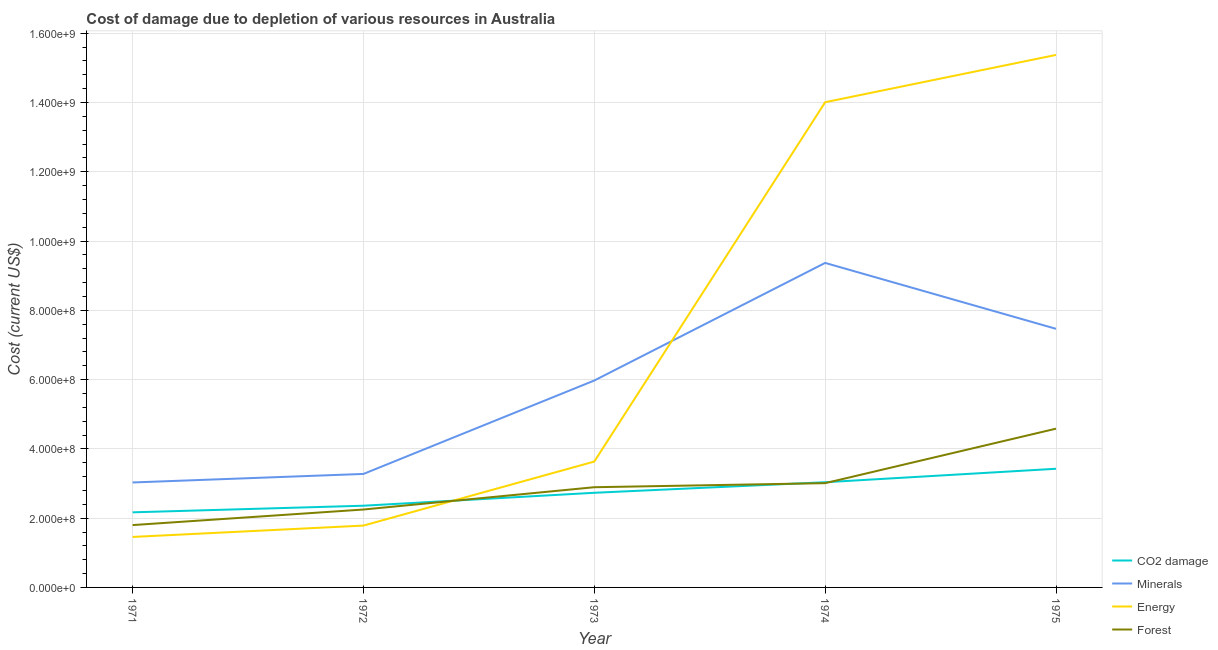Does the line corresponding to cost of damage due to depletion of coal intersect with the line corresponding to cost of damage due to depletion of energy?
Provide a succinct answer. Yes. What is the cost of damage due to depletion of energy in 1974?
Your response must be concise. 1.40e+09. Across all years, what is the maximum cost of damage due to depletion of coal?
Offer a very short reply. 3.43e+08. Across all years, what is the minimum cost of damage due to depletion of minerals?
Offer a terse response. 3.03e+08. In which year was the cost of damage due to depletion of minerals maximum?
Offer a terse response. 1974. What is the total cost of damage due to depletion of coal in the graph?
Offer a terse response. 1.37e+09. What is the difference between the cost of damage due to depletion of minerals in 1971 and that in 1972?
Keep it short and to the point. -2.46e+07. What is the difference between the cost of damage due to depletion of energy in 1975 and the cost of damage due to depletion of coal in 1971?
Provide a succinct answer. 1.32e+09. What is the average cost of damage due to depletion of coal per year?
Provide a succinct answer. 2.74e+08. In the year 1972, what is the difference between the cost of damage due to depletion of energy and cost of damage due to depletion of minerals?
Give a very brief answer. -1.49e+08. What is the ratio of the cost of damage due to depletion of energy in 1971 to that in 1972?
Your answer should be compact. 0.82. Is the cost of damage due to depletion of minerals in 1972 less than that in 1974?
Your answer should be very brief. Yes. Is the difference between the cost of damage due to depletion of energy in 1973 and 1975 greater than the difference between the cost of damage due to depletion of minerals in 1973 and 1975?
Ensure brevity in your answer.  No. What is the difference between the highest and the second highest cost of damage due to depletion of coal?
Your response must be concise. 3.89e+07. What is the difference between the highest and the lowest cost of damage due to depletion of energy?
Keep it short and to the point. 1.39e+09. In how many years, is the cost of damage due to depletion of minerals greater than the average cost of damage due to depletion of minerals taken over all years?
Make the answer very short. 3. Is it the case that in every year, the sum of the cost of damage due to depletion of minerals and cost of damage due to depletion of forests is greater than the sum of cost of damage due to depletion of coal and cost of damage due to depletion of energy?
Provide a short and direct response. No. Does the cost of damage due to depletion of coal monotonically increase over the years?
Your answer should be compact. Yes. How many lines are there?
Give a very brief answer. 4. What is the difference between two consecutive major ticks on the Y-axis?
Provide a succinct answer. 2.00e+08. How many legend labels are there?
Offer a very short reply. 4. What is the title of the graph?
Provide a succinct answer. Cost of damage due to depletion of various resources in Australia . What is the label or title of the X-axis?
Your answer should be compact. Year. What is the label or title of the Y-axis?
Keep it short and to the point. Cost (current US$). What is the Cost (current US$) in CO2 damage in 1971?
Provide a short and direct response. 2.17e+08. What is the Cost (current US$) in Minerals in 1971?
Offer a very short reply. 3.03e+08. What is the Cost (current US$) in Energy in 1971?
Offer a very short reply. 1.46e+08. What is the Cost (current US$) in Forest in 1971?
Ensure brevity in your answer.  1.80e+08. What is the Cost (current US$) in CO2 damage in 1972?
Give a very brief answer. 2.36e+08. What is the Cost (current US$) in Minerals in 1972?
Provide a short and direct response. 3.28e+08. What is the Cost (current US$) in Energy in 1972?
Make the answer very short. 1.79e+08. What is the Cost (current US$) in Forest in 1972?
Offer a very short reply. 2.25e+08. What is the Cost (current US$) in CO2 damage in 1973?
Offer a terse response. 2.73e+08. What is the Cost (current US$) of Minerals in 1973?
Offer a terse response. 5.97e+08. What is the Cost (current US$) of Energy in 1973?
Offer a very short reply. 3.63e+08. What is the Cost (current US$) in Forest in 1973?
Give a very brief answer. 2.89e+08. What is the Cost (current US$) of CO2 damage in 1974?
Provide a succinct answer. 3.04e+08. What is the Cost (current US$) in Minerals in 1974?
Give a very brief answer. 9.37e+08. What is the Cost (current US$) in Energy in 1974?
Give a very brief answer. 1.40e+09. What is the Cost (current US$) of Forest in 1974?
Give a very brief answer. 3.01e+08. What is the Cost (current US$) in CO2 damage in 1975?
Offer a very short reply. 3.43e+08. What is the Cost (current US$) of Minerals in 1975?
Your answer should be compact. 7.47e+08. What is the Cost (current US$) in Energy in 1975?
Make the answer very short. 1.54e+09. What is the Cost (current US$) in Forest in 1975?
Keep it short and to the point. 4.58e+08. Across all years, what is the maximum Cost (current US$) of CO2 damage?
Offer a very short reply. 3.43e+08. Across all years, what is the maximum Cost (current US$) in Minerals?
Your answer should be very brief. 9.37e+08. Across all years, what is the maximum Cost (current US$) in Energy?
Your answer should be compact. 1.54e+09. Across all years, what is the maximum Cost (current US$) of Forest?
Your answer should be compact. 4.58e+08. Across all years, what is the minimum Cost (current US$) in CO2 damage?
Offer a very short reply. 2.17e+08. Across all years, what is the minimum Cost (current US$) of Minerals?
Ensure brevity in your answer.  3.03e+08. Across all years, what is the minimum Cost (current US$) of Energy?
Provide a succinct answer. 1.46e+08. Across all years, what is the minimum Cost (current US$) of Forest?
Your response must be concise. 1.80e+08. What is the total Cost (current US$) in CO2 damage in the graph?
Provide a succinct answer. 1.37e+09. What is the total Cost (current US$) of Minerals in the graph?
Offer a very short reply. 2.91e+09. What is the total Cost (current US$) of Energy in the graph?
Provide a short and direct response. 3.63e+09. What is the total Cost (current US$) in Forest in the graph?
Offer a very short reply. 1.45e+09. What is the difference between the Cost (current US$) of CO2 damage in 1971 and that in 1972?
Offer a very short reply. -1.91e+07. What is the difference between the Cost (current US$) in Minerals in 1971 and that in 1972?
Give a very brief answer. -2.46e+07. What is the difference between the Cost (current US$) in Energy in 1971 and that in 1972?
Provide a short and direct response. -3.28e+07. What is the difference between the Cost (current US$) in Forest in 1971 and that in 1972?
Keep it short and to the point. -4.49e+07. What is the difference between the Cost (current US$) in CO2 damage in 1971 and that in 1973?
Offer a terse response. -5.64e+07. What is the difference between the Cost (current US$) of Minerals in 1971 and that in 1973?
Your answer should be very brief. -2.94e+08. What is the difference between the Cost (current US$) of Energy in 1971 and that in 1973?
Your response must be concise. -2.18e+08. What is the difference between the Cost (current US$) in Forest in 1971 and that in 1973?
Keep it short and to the point. -1.09e+08. What is the difference between the Cost (current US$) of CO2 damage in 1971 and that in 1974?
Your answer should be very brief. -8.69e+07. What is the difference between the Cost (current US$) in Minerals in 1971 and that in 1974?
Your answer should be compact. -6.34e+08. What is the difference between the Cost (current US$) of Energy in 1971 and that in 1974?
Ensure brevity in your answer.  -1.26e+09. What is the difference between the Cost (current US$) of Forest in 1971 and that in 1974?
Ensure brevity in your answer.  -1.21e+08. What is the difference between the Cost (current US$) of CO2 damage in 1971 and that in 1975?
Offer a very short reply. -1.26e+08. What is the difference between the Cost (current US$) in Minerals in 1971 and that in 1975?
Provide a succinct answer. -4.44e+08. What is the difference between the Cost (current US$) of Energy in 1971 and that in 1975?
Give a very brief answer. -1.39e+09. What is the difference between the Cost (current US$) in Forest in 1971 and that in 1975?
Provide a short and direct response. -2.78e+08. What is the difference between the Cost (current US$) in CO2 damage in 1972 and that in 1973?
Give a very brief answer. -3.73e+07. What is the difference between the Cost (current US$) of Minerals in 1972 and that in 1973?
Your answer should be very brief. -2.70e+08. What is the difference between the Cost (current US$) of Energy in 1972 and that in 1973?
Your response must be concise. -1.85e+08. What is the difference between the Cost (current US$) in Forest in 1972 and that in 1973?
Offer a terse response. -6.44e+07. What is the difference between the Cost (current US$) of CO2 damage in 1972 and that in 1974?
Offer a terse response. -6.78e+07. What is the difference between the Cost (current US$) in Minerals in 1972 and that in 1974?
Your response must be concise. -6.09e+08. What is the difference between the Cost (current US$) in Energy in 1972 and that in 1974?
Make the answer very short. -1.22e+09. What is the difference between the Cost (current US$) in Forest in 1972 and that in 1974?
Your answer should be very brief. -7.61e+07. What is the difference between the Cost (current US$) of CO2 damage in 1972 and that in 1975?
Offer a terse response. -1.07e+08. What is the difference between the Cost (current US$) in Minerals in 1972 and that in 1975?
Provide a short and direct response. -4.19e+08. What is the difference between the Cost (current US$) in Energy in 1972 and that in 1975?
Your answer should be very brief. -1.36e+09. What is the difference between the Cost (current US$) in Forest in 1972 and that in 1975?
Provide a short and direct response. -2.33e+08. What is the difference between the Cost (current US$) of CO2 damage in 1973 and that in 1974?
Offer a terse response. -3.04e+07. What is the difference between the Cost (current US$) of Minerals in 1973 and that in 1974?
Make the answer very short. -3.40e+08. What is the difference between the Cost (current US$) of Energy in 1973 and that in 1974?
Ensure brevity in your answer.  -1.04e+09. What is the difference between the Cost (current US$) of Forest in 1973 and that in 1974?
Provide a succinct answer. -1.17e+07. What is the difference between the Cost (current US$) in CO2 damage in 1973 and that in 1975?
Ensure brevity in your answer.  -6.93e+07. What is the difference between the Cost (current US$) of Minerals in 1973 and that in 1975?
Provide a short and direct response. -1.49e+08. What is the difference between the Cost (current US$) in Energy in 1973 and that in 1975?
Make the answer very short. -1.17e+09. What is the difference between the Cost (current US$) in Forest in 1973 and that in 1975?
Offer a very short reply. -1.69e+08. What is the difference between the Cost (current US$) of CO2 damage in 1974 and that in 1975?
Your answer should be very brief. -3.89e+07. What is the difference between the Cost (current US$) in Minerals in 1974 and that in 1975?
Offer a very short reply. 1.90e+08. What is the difference between the Cost (current US$) of Energy in 1974 and that in 1975?
Ensure brevity in your answer.  -1.37e+08. What is the difference between the Cost (current US$) of Forest in 1974 and that in 1975?
Your answer should be very brief. -1.57e+08. What is the difference between the Cost (current US$) in CO2 damage in 1971 and the Cost (current US$) in Minerals in 1972?
Provide a succinct answer. -1.11e+08. What is the difference between the Cost (current US$) in CO2 damage in 1971 and the Cost (current US$) in Energy in 1972?
Offer a terse response. 3.82e+07. What is the difference between the Cost (current US$) of CO2 damage in 1971 and the Cost (current US$) of Forest in 1972?
Give a very brief answer. -8.11e+06. What is the difference between the Cost (current US$) in Minerals in 1971 and the Cost (current US$) in Energy in 1972?
Provide a short and direct response. 1.24e+08. What is the difference between the Cost (current US$) in Minerals in 1971 and the Cost (current US$) in Forest in 1972?
Ensure brevity in your answer.  7.81e+07. What is the difference between the Cost (current US$) of Energy in 1971 and the Cost (current US$) of Forest in 1972?
Your answer should be very brief. -7.92e+07. What is the difference between the Cost (current US$) in CO2 damage in 1971 and the Cost (current US$) in Minerals in 1973?
Offer a terse response. -3.81e+08. What is the difference between the Cost (current US$) of CO2 damage in 1971 and the Cost (current US$) of Energy in 1973?
Your response must be concise. -1.47e+08. What is the difference between the Cost (current US$) in CO2 damage in 1971 and the Cost (current US$) in Forest in 1973?
Keep it short and to the point. -7.25e+07. What is the difference between the Cost (current US$) of Minerals in 1971 and the Cost (current US$) of Energy in 1973?
Make the answer very short. -6.04e+07. What is the difference between the Cost (current US$) of Minerals in 1971 and the Cost (current US$) of Forest in 1973?
Offer a terse response. 1.37e+07. What is the difference between the Cost (current US$) of Energy in 1971 and the Cost (current US$) of Forest in 1973?
Your answer should be very brief. -1.44e+08. What is the difference between the Cost (current US$) in CO2 damage in 1971 and the Cost (current US$) in Minerals in 1974?
Offer a terse response. -7.20e+08. What is the difference between the Cost (current US$) of CO2 damage in 1971 and the Cost (current US$) of Energy in 1974?
Make the answer very short. -1.18e+09. What is the difference between the Cost (current US$) in CO2 damage in 1971 and the Cost (current US$) in Forest in 1974?
Provide a succinct answer. -8.42e+07. What is the difference between the Cost (current US$) in Minerals in 1971 and the Cost (current US$) in Energy in 1974?
Make the answer very short. -1.10e+09. What is the difference between the Cost (current US$) in Minerals in 1971 and the Cost (current US$) in Forest in 1974?
Ensure brevity in your answer.  1.98e+06. What is the difference between the Cost (current US$) of Energy in 1971 and the Cost (current US$) of Forest in 1974?
Offer a very short reply. -1.55e+08. What is the difference between the Cost (current US$) in CO2 damage in 1971 and the Cost (current US$) in Minerals in 1975?
Ensure brevity in your answer.  -5.30e+08. What is the difference between the Cost (current US$) in CO2 damage in 1971 and the Cost (current US$) in Energy in 1975?
Ensure brevity in your answer.  -1.32e+09. What is the difference between the Cost (current US$) of CO2 damage in 1971 and the Cost (current US$) of Forest in 1975?
Your answer should be very brief. -2.42e+08. What is the difference between the Cost (current US$) in Minerals in 1971 and the Cost (current US$) in Energy in 1975?
Ensure brevity in your answer.  -1.23e+09. What is the difference between the Cost (current US$) of Minerals in 1971 and the Cost (current US$) of Forest in 1975?
Your answer should be very brief. -1.55e+08. What is the difference between the Cost (current US$) of Energy in 1971 and the Cost (current US$) of Forest in 1975?
Make the answer very short. -3.13e+08. What is the difference between the Cost (current US$) of CO2 damage in 1972 and the Cost (current US$) of Minerals in 1973?
Your answer should be very brief. -3.61e+08. What is the difference between the Cost (current US$) of CO2 damage in 1972 and the Cost (current US$) of Energy in 1973?
Your answer should be compact. -1.27e+08. What is the difference between the Cost (current US$) in CO2 damage in 1972 and the Cost (current US$) in Forest in 1973?
Your response must be concise. -5.34e+07. What is the difference between the Cost (current US$) in Minerals in 1972 and the Cost (current US$) in Energy in 1973?
Ensure brevity in your answer.  -3.57e+07. What is the difference between the Cost (current US$) of Minerals in 1972 and the Cost (current US$) of Forest in 1973?
Your answer should be very brief. 3.83e+07. What is the difference between the Cost (current US$) in Energy in 1972 and the Cost (current US$) in Forest in 1973?
Offer a terse response. -1.11e+08. What is the difference between the Cost (current US$) in CO2 damage in 1972 and the Cost (current US$) in Minerals in 1974?
Your answer should be very brief. -7.01e+08. What is the difference between the Cost (current US$) in CO2 damage in 1972 and the Cost (current US$) in Energy in 1974?
Make the answer very short. -1.16e+09. What is the difference between the Cost (current US$) of CO2 damage in 1972 and the Cost (current US$) of Forest in 1974?
Your answer should be compact. -6.51e+07. What is the difference between the Cost (current US$) in Minerals in 1972 and the Cost (current US$) in Energy in 1974?
Ensure brevity in your answer.  -1.07e+09. What is the difference between the Cost (current US$) in Minerals in 1972 and the Cost (current US$) in Forest in 1974?
Offer a very short reply. 2.66e+07. What is the difference between the Cost (current US$) of Energy in 1972 and the Cost (current US$) of Forest in 1974?
Your answer should be compact. -1.22e+08. What is the difference between the Cost (current US$) of CO2 damage in 1972 and the Cost (current US$) of Minerals in 1975?
Provide a succinct answer. -5.11e+08. What is the difference between the Cost (current US$) in CO2 damage in 1972 and the Cost (current US$) in Energy in 1975?
Keep it short and to the point. -1.30e+09. What is the difference between the Cost (current US$) of CO2 damage in 1972 and the Cost (current US$) of Forest in 1975?
Offer a very short reply. -2.22e+08. What is the difference between the Cost (current US$) in Minerals in 1972 and the Cost (current US$) in Energy in 1975?
Offer a very short reply. -1.21e+09. What is the difference between the Cost (current US$) of Minerals in 1972 and the Cost (current US$) of Forest in 1975?
Offer a very short reply. -1.31e+08. What is the difference between the Cost (current US$) of Energy in 1972 and the Cost (current US$) of Forest in 1975?
Provide a short and direct response. -2.80e+08. What is the difference between the Cost (current US$) of CO2 damage in 1973 and the Cost (current US$) of Minerals in 1974?
Ensure brevity in your answer.  -6.64e+08. What is the difference between the Cost (current US$) in CO2 damage in 1973 and the Cost (current US$) in Energy in 1974?
Provide a short and direct response. -1.13e+09. What is the difference between the Cost (current US$) of CO2 damage in 1973 and the Cost (current US$) of Forest in 1974?
Offer a terse response. -2.78e+07. What is the difference between the Cost (current US$) of Minerals in 1973 and the Cost (current US$) of Energy in 1974?
Offer a terse response. -8.03e+08. What is the difference between the Cost (current US$) in Minerals in 1973 and the Cost (current US$) in Forest in 1974?
Provide a succinct answer. 2.96e+08. What is the difference between the Cost (current US$) of Energy in 1973 and the Cost (current US$) of Forest in 1974?
Offer a terse response. 6.23e+07. What is the difference between the Cost (current US$) in CO2 damage in 1973 and the Cost (current US$) in Minerals in 1975?
Make the answer very short. -4.73e+08. What is the difference between the Cost (current US$) of CO2 damage in 1973 and the Cost (current US$) of Energy in 1975?
Offer a very short reply. -1.26e+09. What is the difference between the Cost (current US$) in CO2 damage in 1973 and the Cost (current US$) in Forest in 1975?
Your response must be concise. -1.85e+08. What is the difference between the Cost (current US$) in Minerals in 1973 and the Cost (current US$) in Energy in 1975?
Give a very brief answer. -9.40e+08. What is the difference between the Cost (current US$) in Minerals in 1973 and the Cost (current US$) in Forest in 1975?
Your response must be concise. 1.39e+08. What is the difference between the Cost (current US$) in Energy in 1973 and the Cost (current US$) in Forest in 1975?
Give a very brief answer. -9.50e+07. What is the difference between the Cost (current US$) of CO2 damage in 1974 and the Cost (current US$) of Minerals in 1975?
Offer a very short reply. -4.43e+08. What is the difference between the Cost (current US$) in CO2 damage in 1974 and the Cost (current US$) in Energy in 1975?
Provide a succinct answer. -1.23e+09. What is the difference between the Cost (current US$) in CO2 damage in 1974 and the Cost (current US$) in Forest in 1975?
Provide a short and direct response. -1.55e+08. What is the difference between the Cost (current US$) in Minerals in 1974 and the Cost (current US$) in Energy in 1975?
Ensure brevity in your answer.  -6.00e+08. What is the difference between the Cost (current US$) in Minerals in 1974 and the Cost (current US$) in Forest in 1975?
Keep it short and to the point. 4.79e+08. What is the difference between the Cost (current US$) in Energy in 1974 and the Cost (current US$) in Forest in 1975?
Make the answer very short. 9.43e+08. What is the average Cost (current US$) in CO2 damage per year?
Provide a short and direct response. 2.74e+08. What is the average Cost (current US$) in Minerals per year?
Your answer should be compact. 5.82e+08. What is the average Cost (current US$) in Energy per year?
Keep it short and to the point. 7.25e+08. What is the average Cost (current US$) in Forest per year?
Keep it short and to the point. 2.91e+08. In the year 1971, what is the difference between the Cost (current US$) in CO2 damage and Cost (current US$) in Minerals?
Give a very brief answer. -8.62e+07. In the year 1971, what is the difference between the Cost (current US$) in CO2 damage and Cost (current US$) in Energy?
Your answer should be very brief. 7.10e+07. In the year 1971, what is the difference between the Cost (current US$) of CO2 damage and Cost (current US$) of Forest?
Ensure brevity in your answer.  3.68e+07. In the year 1971, what is the difference between the Cost (current US$) of Minerals and Cost (current US$) of Energy?
Your answer should be compact. 1.57e+08. In the year 1971, what is the difference between the Cost (current US$) of Minerals and Cost (current US$) of Forest?
Provide a succinct answer. 1.23e+08. In the year 1971, what is the difference between the Cost (current US$) of Energy and Cost (current US$) of Forest?
Give a very brief answer. -3.42e+07. In the year 1972, what is the difference between the Cost (current US$) of CO2 damage and Cost (current US$) of Minerals?
Keep it short and to the point. -9.18e+07. In the year 1972, what is the difference between the Cost (current US$) in CO2 damage and Cost (current US$) in Energy?
Provide a succinct answer. 5.73e+07. In the year 1972, what is the difference between the Cost (current US$) in CO2 damage and Cost (current US$) in Forest?
Your response must be concise. 1.10e+07. In the year 1972, what is the difference between the Cost (current US$) in Minerals and Cost (current US$) in Energy?
Provide a succinct answer. 1.49e+08. In the year 1972, what is the difference between the Cost (current US$) in Minerals and Cost (current US$) in Forest?
Your response must be concise. 1.03e+08. In the year 1972, what is the difference between the Cost (current US$) in Energy and Cost (current US$) in Forest?
Offer a very short reply. -4.64e+07. In the year 1973, what is the difference between the Cost (current US$) in CO2 damage and Cost (current US$) in Minerals?
Offer a terse response. -3.24e+08. In the year 1973, what is the difference between the Cost (current US$) of CO2 damage and Cost (current US$) of Energy?
Your response must be concise. -9.01e+07. In the year 1973, what is the difference between the Cost (current US$) in CO2 damage and Cost (current US$) in Forest?
Ensure brevity in your answer.  -1.61e+07. In the year 1973, what is the difference between the Cost (current US$) in Minerals and Cost (current US$) in Energy?
Offer a very short reply. 2.34e+08. In the year 1973, what is the difference between the Cost (current US$) in Minerals and Cost (current US$) in Forest?
Your answer should be compact. 3.08e+08. In the year 1973, what is the difference between the Cost (current US$) in Energy and Cost (current US$) in Forest?
Provide a succinct answer. 7.41e+07. In the year 1974, what is the difference between the Cost (current US$) in CO2 damage and Cost (current US$) in Minerals?
Provide a short and direct response. -6.33e+08. In the year 1974, what is the difference between the Cost (current US$) of CO2 damage and Cost (current US$) of Energy?
Your response must be concise. -1.10e+09. In the year 1974, what is the difference between the Cost (current US$) of CO2 damage and Cost (current US$) of Forest?
Your response must be concise. 2.66e+06. In the year 1974, what is the difference between the Cost (current US$) of Minerals and Cost (current US$) of Energy?
Provide a succinct answer. -4.64e+08. In the year 1974, what is the difference between the Cost (current US$) in Minerals and Cost (current US$) in Forest?
Ensure brevity in your answer.  6.36e+08. In the year 1974, what is the difference between the Cost (current US$) of Energy and Cost (current US$) of Forest?
Give a very brief answer. 1.10e+09. In the year 1975, what is the difference between the Cost (current US$) of CO2 damage and Cost (current US$) of Minerals?
Your answer should be compact. -4.04e+08. In the year 1975, what is the difference between the Cost (current US$) of CO2 damage and Cost (current US$) of Energy?
Provide a succinct answer. -1.19e+09. In the year 1975, what is the difference between the Cost (current US$) in CO2 damage and Cost (current US$) in Forest?
Ensure brevity in your answer.  -1.16e+08. In the year 1975, what is the difference between the Cost (current US$) of Minerals and Cost (current US$) of Energy?
Keep it short and to the point. -7.91e+08. In the year 1975, what is the difference between the Cost (current US$) of Minerals and Cost (current US$) of Forest?
Ensure brevity in your answer.  2.88e+08. In the year 1975, what is the difference between the Cost (current US$) of Energy and Cost (current US$) of Forest?
Make the answer very short. 1.08e+09. What is the ratio of the Cost (current US$) of CO2 damage in 1971 to that in 1972?
Your response must be concise. 0.92. What is the ratio of the Cost (current US$) of Minerals in 1971 to that in 1972?
Provide a short and direct response. 0.92. What is the ratio of the Cost (current US$) in Energy in 1971 to that in 1972?
Your answer should be compact. 0.82. What is the ratio of the Cost (current US$) of Forest in 1971 to that in 1972?
Make the answer very short. 0.8. What is the ratio of the Cost (current US$) in CO2 damage in 1971 to that in 1973?
Give a very brief answer. 0.79. What is the ratio of the Cost (current US$) in Minerals in 1971 to that in 1973?
Provide a short and direct response. 0.51. What is the ratio of the Cost (current US$) of Energy in 1971 to that in 1973?
Your answer should be compact. 0.4. What is the ratio of the Cost (current US$) of Forest in 1971 to that in 1973?
Keep it short and to the point. 0.62. What is the ratio of the Cost (current US$) of CO2 damage in 1971 to that in 1974?
Provide a short and direct response. 0.71. What is the ratio of the Cost (current US$) of Minerals in 1971 to that in 1974?
Your response must be concise. 0.32. What is the ratio of the Cost (current US$) in Energy in 1971 to that in 1974?
Give a very brief answer. 0.1. What is the ratio of the Cost (current US$) of Forest in 1971 to that in 1974?
Keep it short and to the point. 0.6. What is the ratio of the Cost (current US$) of CO2 damage in 1971 to that in 1975?
Ensure brevity in your answer.  0.63. What is the ratio of the Cost (current US$) in Minerals in 1971 to that in 1975?
Offer a very short reply. 0.41. What is the ratio of the Cost (current US$) in Energy in 1971 to that in 1975?
Offer a very short reply. 0.09. What is the ratio of the Cost (current US$) of Forest in 1971 to that in 1975?
Provide a short and direct response. 0.39. What is the ratio of the Cost (current US$) in CO2 damage in 1972 to that in 1973?
Give a very brief answer. 0.86. What is the ratio of the Cost (current US$) of Minerals in 1972 to that in 1973?
Provide a short and direct response. 0.55. What is the ratio of the Cost (current US$) of Energy in 1972 to that in 1973?
Ensure brevity in your answer.  0.49. What is the ratio of the Cost (current US$) of Forest in 1972 to that in 1973?
Provide a succinct answer. 0.78. What is the ratio of the Cost (current US$) in CO2 damage in 1972 to that in 1974?
Offer a terse response. 0.78. What is the ratio of the Cost (current US$) of Minerals in 1972 to that in 1974?
Make the answer very short. 0.35. What is the ratio of the Cost (current US$) in Energy in 1972 to that in 1974?
Your answer should be very brief. 0.13. What is the ratio of the Cost (current US$) in Forest in 1972 to that in 1974?
Give a very brief answer. 0.75. What is the ratio of the Cost (current US$) in CO2 damage in 1972 to that in 1975?
Keep it short and to the point. 0.69. What is the ratio of the Cost (current US$) of Minerals in 1972 to that in 1975?
Provide a short and direct response. 0.44. What is the ratio of the Cost (current US$) in Energy in 1972 to that in 1975?
Your response must be concise. 0.12. What is the ratio of the Cost (current US$) in Forest in 1972 to that in 1975?
Offer a terse response. 0.49. What is the ratio of the Cost (current US$) of CO2 damage in 1973 to that in 1974?
Your answer should be very brief. 0.9. What is the ratio of the Cost (current US$) of Minerals in 1973 to that in 1974?
Make the answer very short. 0.64. What is the ratio of the Cost (current US$) of Energy in 1973 to that in 1974?
Provide a succinct answer. 0.26. What is the ratio of the Cost (current US$) of Forest in 1973 to that in 1974?
Provide a succinct answer. 0.96. What is the ratio of the Cost (current US$) in CO2 damage in 1973 to that in 1975?
Provide a succinct answer. 0.8. What is the ratio of the Cost (current US$) in Minerals in 1973 to that in 1975?
Your response must be concise. 0.8. What is the ratio of the Cost (current US$) of Energy in 1973 to that in 1975?
Your response must be concise. 0.24. What is the ratio of the Cost (current US$) in Forest in 1973 to that in 1975?
Provide a succinct answer. 0.63. What is the ratio of the Cost (current US$) of CO2 damage in 1974 to that in 1975?
Your answer should be very brief. 0.89. What is the ratio of the Cost (current US$) of Minerals in 1974 to that in 1975?
Make the answer very short. 1.25. What is the ratio of the Cost (current US$) of Energy in 1974 to that in 1975?
Keep it short and to the point. 0.91. What is the ratio of the Cost (current US$) of Forest in 1974 to that in 1975?
Give a very brief answer. 0.66. What is the difference between the highest and the second highest Cost (current US$) of CO2 damage?
Provide a short and direct response. 3.89e+07. What is the difference between the highest and the second highest Cost (current US$) of Minerals?
Make the answer very short. 1.90e+08. What is the difference between the highest and the second highest Cost (current US$) of Energy?
Your answer should be very brief. 1.37e+08. What is the difference between the highest and the second highest Cost (current US$) of Forest?
Provide a short and direct response. 1.57e+08. What is the difference between the highest and the lowest Cost (current US$) of CO2 damage?
Keep it short and to the point. 1.26e+08. What is the difference between the highest and the lowest Cost (current US$) of Minerals?
Keep it short and to the point. 6.34e+08. What is the difference between the highest and the lowest Cost (current US$) in Energy?
Make the answer very short. 1.39e+09. What is the difference between the highest and the lowest Cost (current US$) in Forest?
Give a very brief answer. 2.78e+08. 